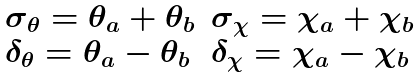Convert formula to latex. <formula><loc_0><loc_0><loc_500><loc_500>\begin{array} { c c } \begin{array} { l } \sigma _ { \theta } = \theta _ { a } + \theta _ { b } \\ \delta _ { \theta } = \theta _ { a } - \theta _ { b } \\ \end{array} \begin{array} { l } \sigma _ { \chi } = \chi _ { a } + \chi _ { b } \\ \delta _ { \chi } = \chi _ { a } - \chi _ { b } \\ \end{array} \end{array}</formula> 